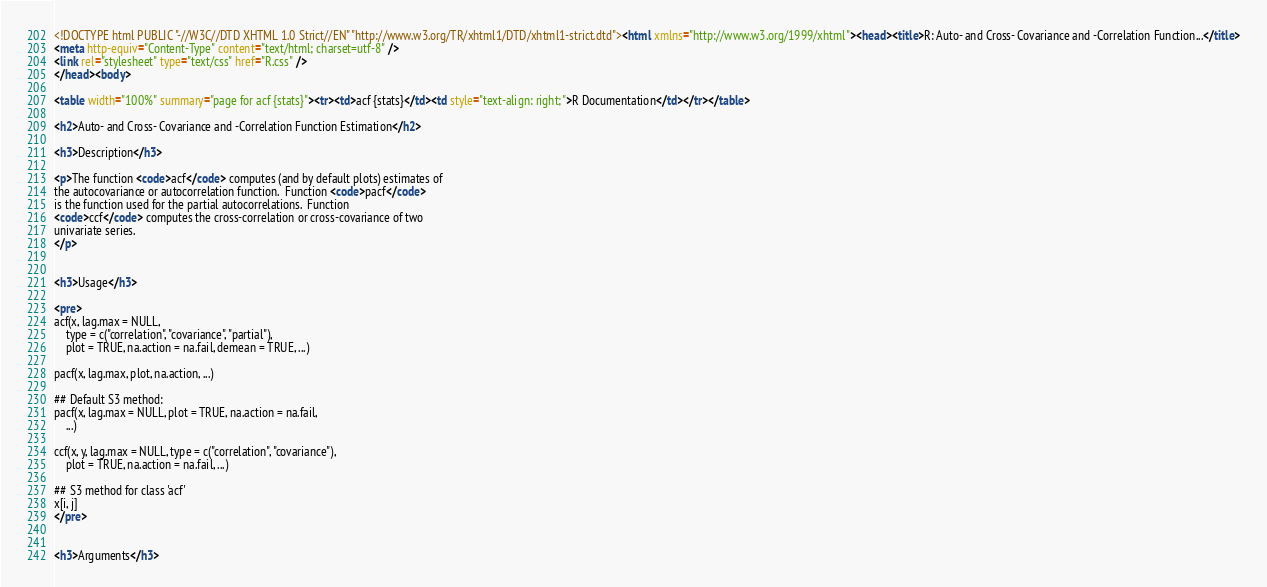<code> <loc_0><loc_0><loc_500><loc_500><_HTML_><!DOCTYPE html PUBLIC "-//W3C//DTD XHTML 1.0 Strict//EN" "http://www.w3.org/TR/xhtml1/DTD/xhtml1-strict.dtd"><html xmlns="http://www.w3.org/1999/xhtml"><head><title>R: Auto- and Cross- Covariance and -Correlation Function...</title>
<meta http-equiv="Content-Type" content="text/html; charset=utf-8" />
<link rel="stylesheet" type="text/css" href="R.css" />
</head><body>

<table width="100%" summary="page for acf {stats}"><tr><td>acf {stats}</td><td style="text-align: right;">R Documentation</td></tr></table>

<h2>Auto- and Cross- Covariance and -Correlation Function Estimation</h2>

<h3>Description</h3>

<p>The function <code>acf</code> computes (and by default plots) estimates of
the autocovariance or autocorrelation function.  Function <code>pacf</code>
is the function used for the partial autocorrelations.  Function
<code>ccf</code> computes the cross-correlation or cross-covariance of two
univariate series.
</p>


<h3>Usage</h3>

<pre>
acf(x, lag.max = NULL,
    type = c("correlation", "covariance", "partial"),
    plot = TRUE, na.action = na.fail, demean = TRUE, ...)

pacf(x, lag.max, plot, na.action, ...)

## Default S3 method:
pacf(x, lag.max = NULL, plot = TRUE, na.action = na.fail,
    ...)

ccf(x, y, lag.max = NULL, type = c("correlation", "covariance"),
    plot = TRUE, na.action = na.fail, ...)

## S3 method for class 'acf'
x[i, j]
</pre>


<h3>Arguments</h3>
</code> 